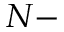Convert formula to latex. <formula><loc_0><loc_0><loc_500><loc_500>N -</formula> 